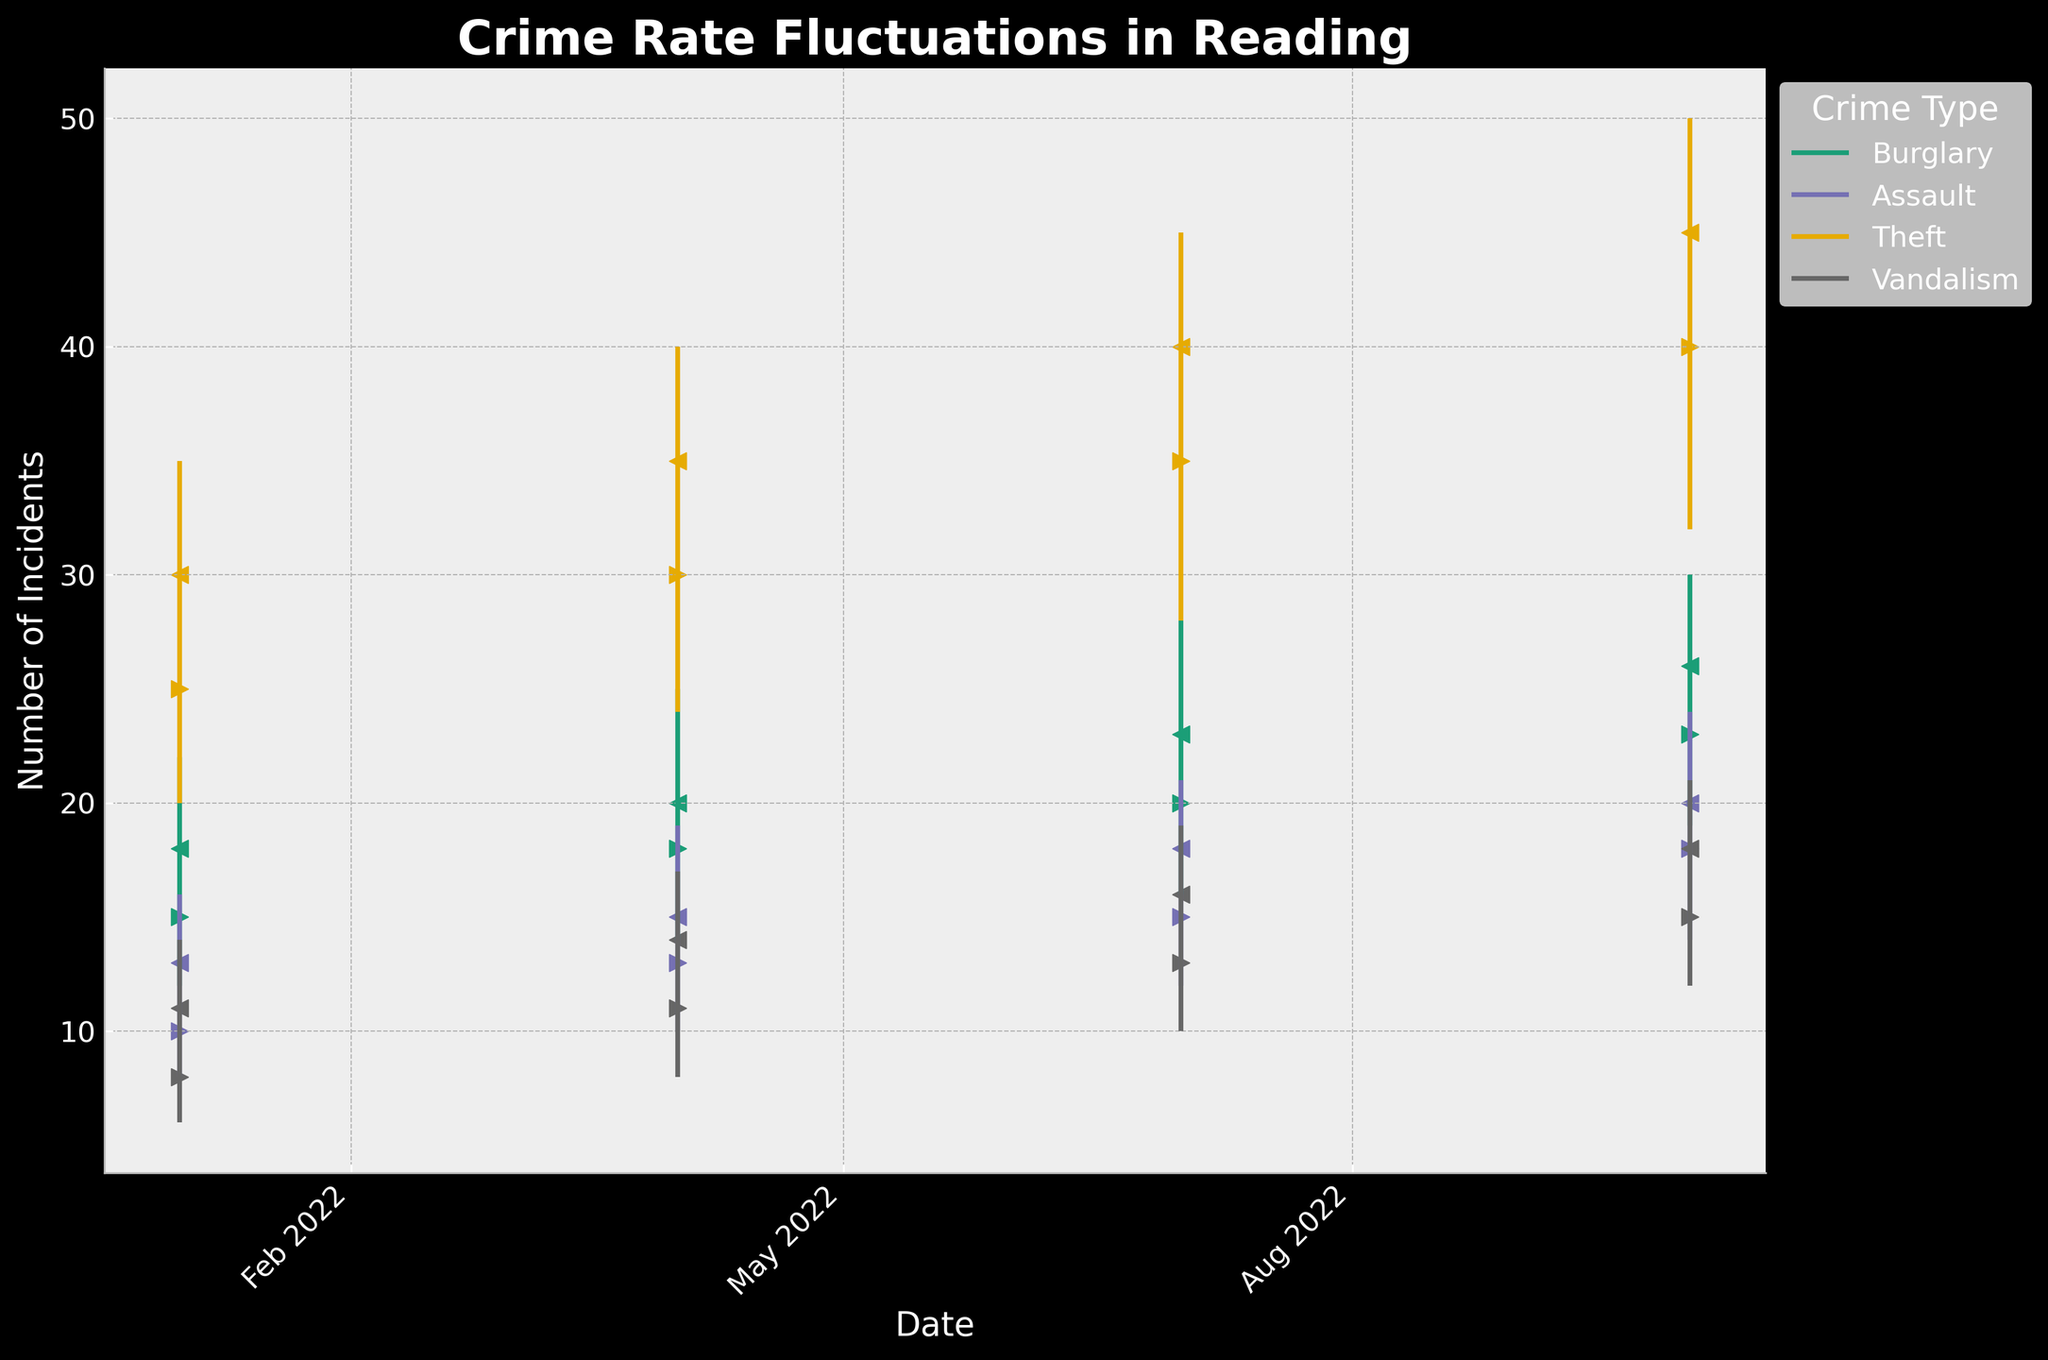What is the title of the chart? The title is located at the top of the chart and is clearly visible. It reads "Crime Rate Fluctuations in Reading."
Answer: Crime Rate Fluctuations in Reading What does the x-axis represent? The x-axis at the bottom of the chart indicates the dates corresponding to the crime data points, formatted in three-month intervals.
Answer: Date Which type of crime showed the highest incident number increase from January 2022 to October 2022? Look at the scatted points representing the highest values in each crime category, and compare their values between these two dates. Theft starts at 25 and ends at 45, showing the maximum increase of 20 incidents.
Answer: Theft How does the trend of assault incidents during the day progress over the year? Observe the vertical lines and scattered points for "Assault" over the given months. The trend shows a steady increase from 10 in January to 13 in April, 15 in July, and 18 in October.
Answer: Steady increase What time of the day sees the most theft incidents? Assess the number of incidents in the "Theft" category, marked for "Evening." Notice that all incidents are plotted higher compared to other categories at different times of the day.
Answer: Evening Between Burglary at Night and Vandalism in the Morning, which showed a greater increase from the start to the end of the period? Compare the data points for Burglary (15 to 26) and Vandalism (8 to 18) from January to October. Calculate the increase: Burglary increased by 11, and Vandalism by 10.
Answer: Burglary Which crime type had a more significant peak value in July 2022? For July 2022, compare the peak (High) values of all crime types. Theft has the highest peak at 45.
Answer: Theft How many types of crime are represented in the chart, and what are they? Check the legend on the right side of the chart, which lists all crime categories: Burglary, Assault, Theft, and Vandalism, summing up to four types.
Answer: Four (Burglary, Assault, Theft, Vandalism) What's the lowest number of vandalism incidents reported in 2022, and in which month did it occur? Identify the lowest recorded number in the "Vandalism" category, which is 6 in January 2022.
Answer: 6 in January 